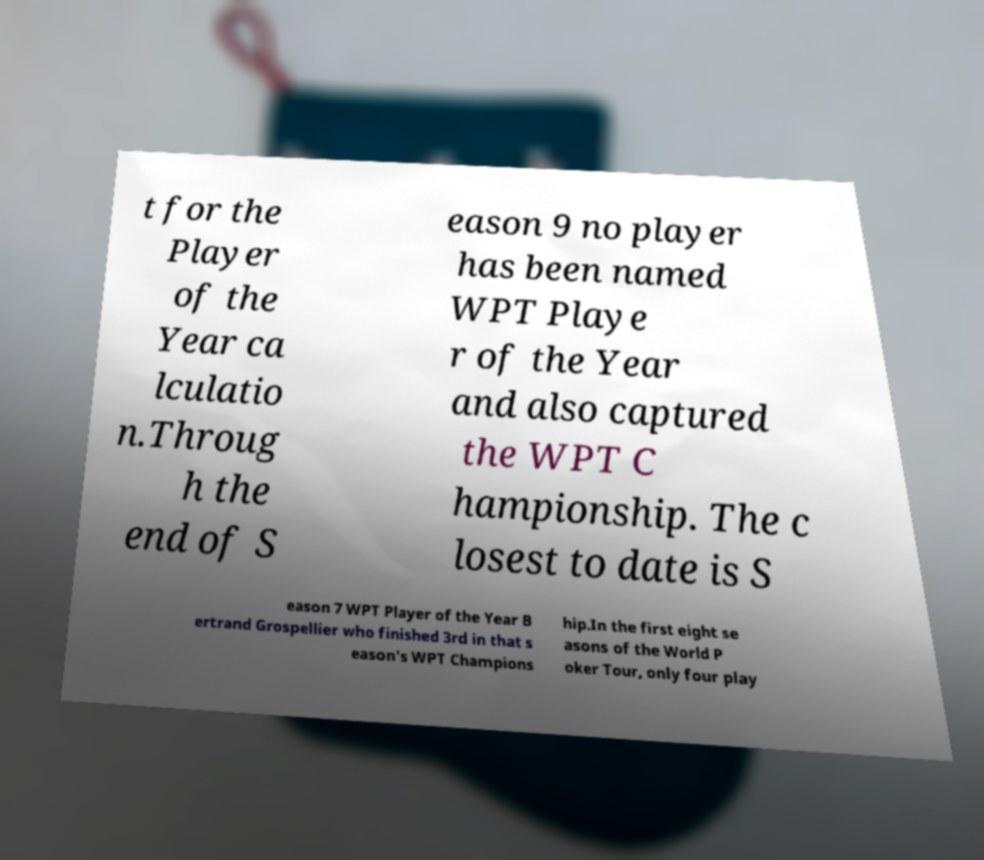Please identify and transcribe the text found in this image. t for the Player of the Year ca lculatio n.Throug h the end of S eason 9 no player has been named WPT Playe r of the Year and also captured the WPT C hampionship. The c losest to date is S eason 7 WPT Player of the Year B ertrand Grospellier who finished 3rd in that s eason's WPT Champions hip.In the first eight se asons of the World P oker Tour, only four play 